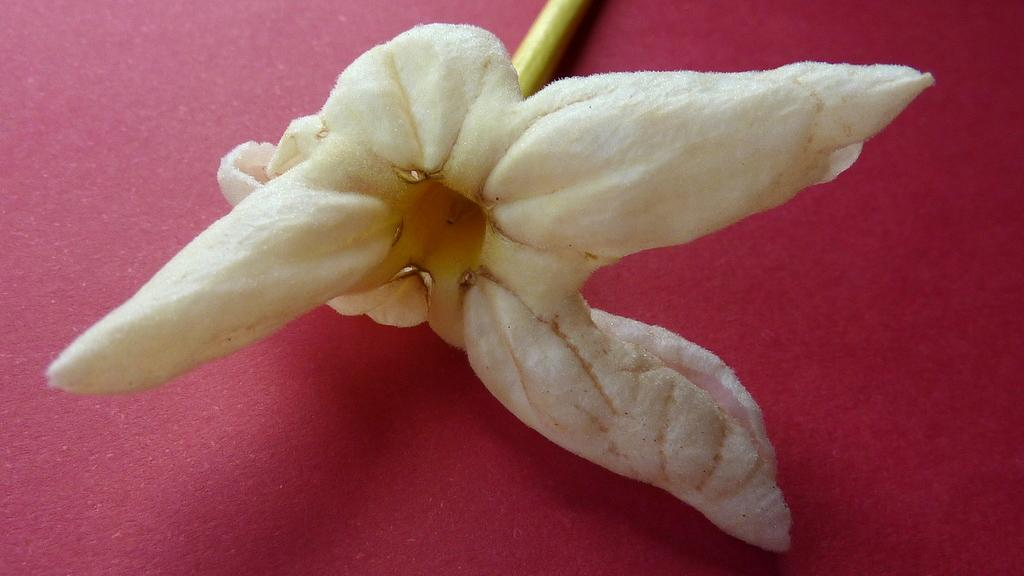What type of plant can be seen in the image? There is a flower in the image. How many legs can be seen on the flower in the image? Flowers do not have legs, so there are no legs visible on the flower in the image. 